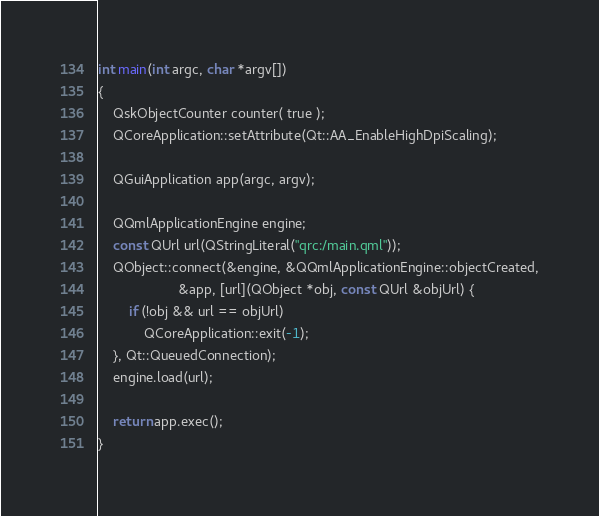Convert code to text. <code><loc_0><loc_0><loc_500><loc_500><_C++_>int main(int argc, char *argv[])
{
    QskObjectCounter counter( true );
    QCoreApplication::setAttribute(Qt::AA_EnableHighDpiScaling);

    QGuiApplication app(argc, argv);

    QQmlApplicationEngine engine;
    const QUrl url(QStringLiteral("qrc:/main.qml"));
    QObject::connect(&engine, &QQmlApplicationEngine::objectCreated,
                     &app, [url](QObject *obj, const QUrl &objUrl) {
        if (!obj && url == objUrl)
            QCoreApplication::exit(-1);
    }, Qt::QueuedConnection);
    engine.load(url);

    return app.exec();
}
</code> 